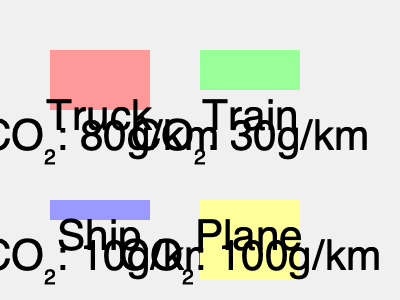Based on the chart showing CO₂ emissions per kilometer for different transportation methods, which mode of transport would be most sustainable for shipping products over a 1000 km distance, and how much CO₂ would be saved compared to the least sustainable option? To determine the most sustainable transportation method and calculate CO₂ savings:

1. Identify CO₂ emissions per km for each method:
   - Truck: 80g/km
   - Train: 30g/km
   - Ship: 10g/km
   - Plane: 100g/km

2. Calculate total CO₂ emissions for 1000 km:
   - Truck: $80 \times 1000 = 80,000g = 80kg$
   - Train: $30 \times 1000 = 30,000g = 30kg$
   - Ship: $10 \times 1000 = 10,000g = 10kg$
   - Plane: $100 \times 1000 = 100,000g = 100kg$

3. Identify the most sustainable (lowest emissions) and least sustainable (highest emissions) options:
   - Most sustainable: Ship (10kg CO₂)
   - Least sustainable: Plane (100kg CO₂)

4. Calculate CO₂ savings:
   $CO₂ saved = CO₂_{plane} - CO₂_{ship} = 100kg - 10kg = 90kg$

Therefore, shipping by sea is the most sustainable option, saving 90kg of CO₂ emissions compared to air freight over a 1000 km distance.
Answer: Ship; 90kg CO₂ saved 